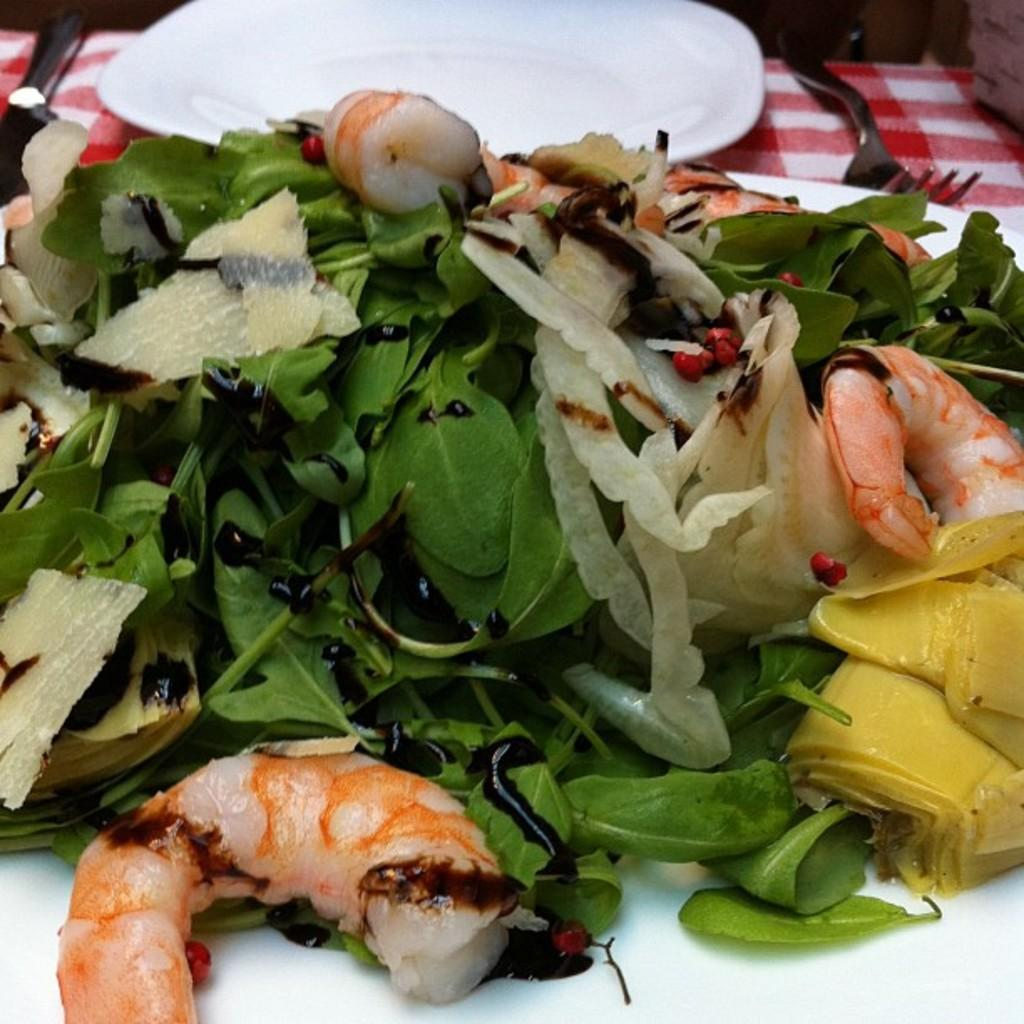What type of food can be seen in the image? There are green vegetables in the image, which is a type of food. What else is present in the image besides the green vegetables? There are forks and a plate visible in the image. Where are these items located? All of these items are on a table. What color are the oranges in the image? There are no oranges present in the image. What story is being told in the image? The image does not depict a story; it shows green vegetables, forks, a plate, and a table. 